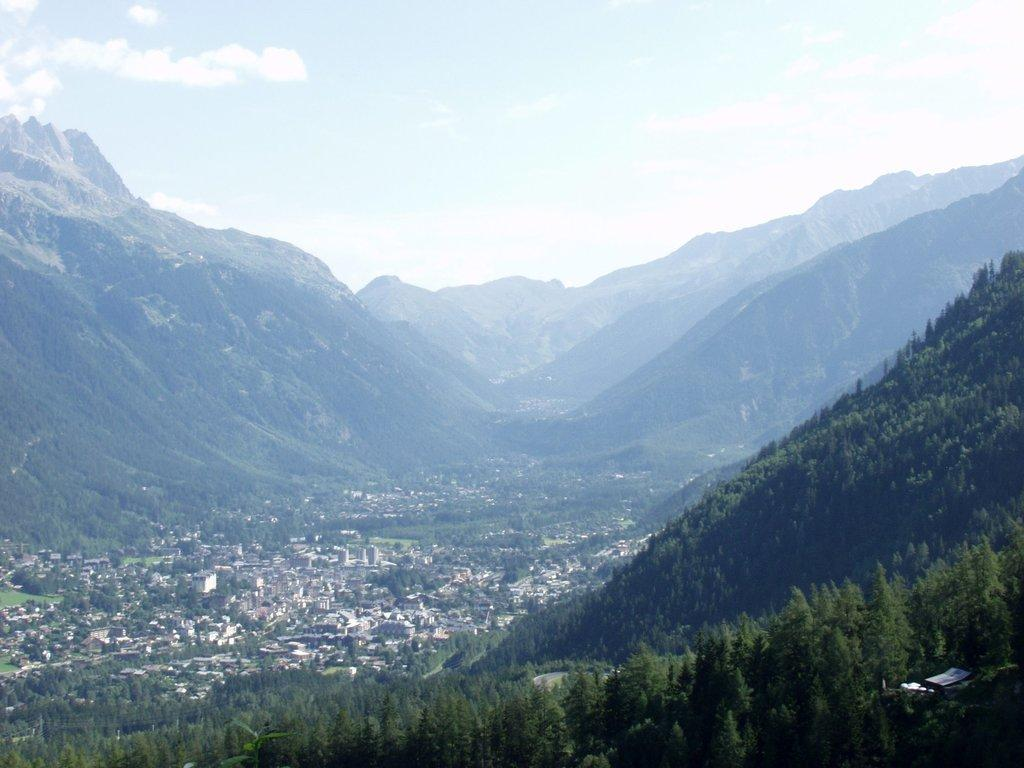What type of vegetation can be seen on the hills in the image? There are trees on the hills in the image. What type of structures are visible in the image? There are houses in the image. What geographical features are present in the image? There are hills visible in the image. What is visible in the background of the image? The sky is visible in the background of the image. What atmospheric conditions can be observed in the sky? Clouds are present in the sky. What type of teaching is taking place in the image? There is no teaching activity present in the image. What type of ray is visible in the image? There is no ray visible in the image. 